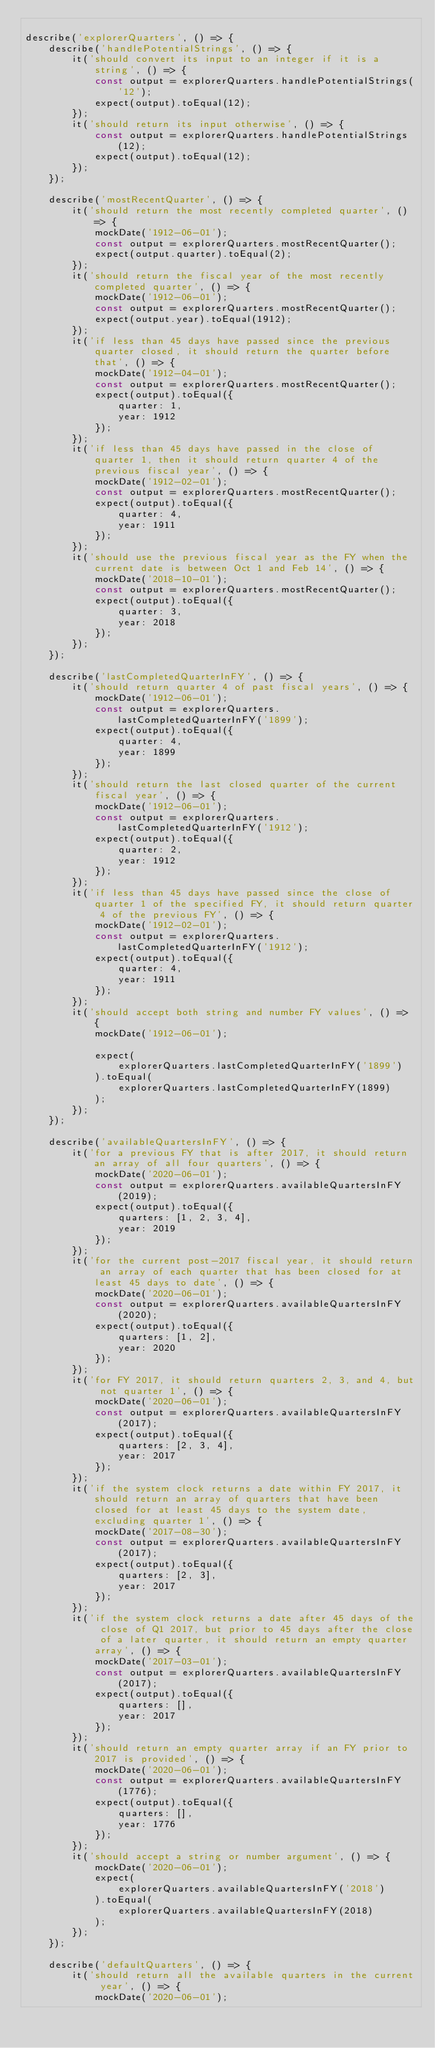<code> <loc_0><loc_0><loc_500><loc_500><_JavaScript_>
describe('explorerQuarters', () => {
    describe('handlePotentialStrings', () => {
        it('should convert its input to an integer if it is a string', () => {
            const output = explorerQuarters.handlePotentialStrings('12');
            expect(output).toEqual(12);
        });
        it('should return its input otherwise', () => {
            const output = explorerQuarters.handlePotentialStrings(12);
            expect(output).toEqual(12);
        });
    });

    describe('mostRecentQuarter', () => {
        it('should return the most recently completed quarter', () => {
            mockDate('1912-06-01');
            const output = explorerQuarters.mostRecentQuarter();
            expect(output.quarter).toEqual(2);
        });
        it('should return the fiscal year of the most recently completed quarter', () => {
            mockDate('1912-06-01');
            const output = explorerQuarters.mostRecentQuarter();
            expect(output.year).toEqual(1912);
        });
        it('if less than 45 days have passed since the previous quarter closed, it should return the quarter before that', () => {
            mockDate('1912-04-01');
            const output = explorerQuarters.mostRecentQuarter();
            expect(output).toEqual({
                quarter: 1,
                year: 1912
            });
        });
        it('if less than 45 days have passed in the close of quarter 1, then it should return quarter 4 of the previous fiscal year', () => {
            mockDate('1912-02-01');
            const output = explorerQuarters.mostRecentQuarter();
            expect(output).toEqual({
                quarter: 4,
                year: 1911
            });
        });
        it('should use the previous fiscal year as the FY when the current date is between Oct 1 and Feb 14', () => {
            mockDate('2018-10-01');
            const output = explorerQuarters.mostRecentQuarter();
            expect(output).toEqual({
                quarter: 3,
                year: 2018
            });
        });
    });

    describe('lastCompletedQuarterInFY', () => {
        it('should return quarter 4 of past fiscal years', () => {
            mockDate('1912-06-01');
            const output = explorerQuarters.lastCompletedQuarterInFY('1899');
            expect(output).toEqual({
                quarter: 4,
                year: 1899
            });
        });
        it('should return the last closed quarter of the current fiscal year', () => {
            mockDate('1912-06-01');
            const output = explorerQuarters.lastCompletedQuarterInFY('1912');
            expect(output).toEqual({
                quarter: 2,
                year: 1912
            });
        });
        it('if less than 45 days have passed since the close of quarter 1 of the specified FY, it should return quarter 4 of the previous FY', () => {
            mockDate('1912-02-01');
            const output = explorerQuarters.lastCompletedQuarterInFY('1912');
            expect(output).toEqual({
                quarter: 4,
                year: 1911
            });
        });
        it('should accept both string and number FY values', () => {
            mockDate('1912-06-01');

            expect(
                explorerQuarters.lastCompletedQuarterInFY('1899')
            ).toEqual(
                explorerQuarters.lastCompletedQuarterInFY(1899)
            );
        });
    });

    describe('availableQuartersInFY', () => {
        it('for a previous FY that is after 2017, it should return an array of all four quarters', () => {
            mockDate('2020-06-01');
            const output = explorerQuarters.availableQuartersInFY(2019);
            expect(output).toEqual({
                quarters: [1, 2, 3, 4],
                year: 2019
            });
        });
        it('for the current post-2017 fiscal year, it should return an array of each quarter that has been closed for at least 45 days to date', () => {
            mockDate('2020-06-01');
            const output = explorerQuarters.availableQuartersInFY(2020);
            expect(output).toEqual({
                quarters: [1, 2],
                year: 2020
            });
        });
        it('for FY 2017, it should return quarters 2, 3, and 4, but not quarter 1', () => {
            mockDate('2020-06-01');
            const output = explorerQuarters.availableQuartersInFY(2017);
            expect(output).toEqual({
                quarters: [2, 3, 4],
                year: 2017
            });
        });
        it('if the system clock returns a date within FY 2017, it should return an array of quarters that have been closed for at least 45 days to the system date, excluding quarter 1', () => {
            mockDate('2017-08-30');
            const output = explorerQuarters.availableQuartersInFY(2017);
            expect(output).toEqual({
                quarters: [2, 3],
                year: 2017
            });
        });
        it('if the system clock returns a date after 45 days of the close of Q1 2017, but prior to 45 days after the close of a later quarter, it should return an empty quarter array', () => {
            mockDate('2017-03-01');
            const output = explorerQuarters.availableQuartersInFY(2017);
            expect(output).toEqual({
                quarters: [],
                year: 2017
            });
        });
        it('should return an empty quarter array if an FY prior to 2017 is provided', () => {
            mockDate('2020-06-01');
            const output = explorerQuarters.availableQuartersInFY(1776);
            expect(output).toEqual({
                quarters: [],
                year: 1776
            });
        });
        it('should accept a string or number argument', () => {
            mockDate('2020-06-01');
            expect(
                explorerQuarters.availableQuartersInFY('2018')
            ).toEqual(
                explorerQuarters.availableQuartersInFY(2018)
            );
        });
    });

    describe('defaultQuarters', () => {
        it('should return all the available quarters in the current year', () => {
            mockDate('2020-06-01');</code> 